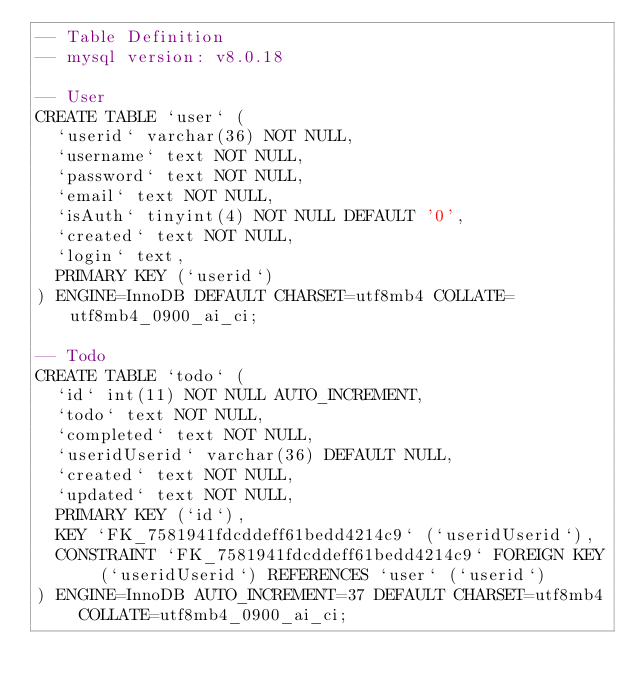<code> <loc_0><loc_0><loc_500><loc_500><_SQL_>-- Table Definition
-- mysql version: v8.0.18

-- User
CREATE TABLE `user` (
  `userid` varchar(36) NOT NULL,
  `username` text NOT NULL,
  `password` text NOT NULL,
  `email` text NOT NULL,
  `isAuth` tinyint(4) NOT NULL DEFAULT '0',
  `created` text NOT NULL,
  `login` text,
  PRIMARY KEY (`userid`)
) ENGINE=InnoDB DEFAULT CHARSET=utf8mb4 COLLATE=utf8mb4_0900_ai_ci;

-- Todo
CREATE TABLE `todo` (
  `id` int(11) NOT NULL AUTO_INCREMENT,
  `todo` text NOT NULL,
  `completed` text NOT NULL,
  `useridUserid` varchar(36) DEFAULT NULL,
  `created` text NOT NULL,
  `updated` text NOT NULL,
  PRIMARY KEY (`id`),
  KEY `FK_7581941fdcddeff61bedd4214c9` (`useridUserid`),
  CONSTRAINT `FK_7581941fdcddeff61bedd4214c9` FOREIGN KEY (`useridUserid`) REFERENCES `user` (`userid`)
) ENGINE=InnoDB AUTO_INCREMENT=37 DEFAULT CHARSET=utf8mb4 COLLATE=utf8mb4_0900_ai_ci;</code> 